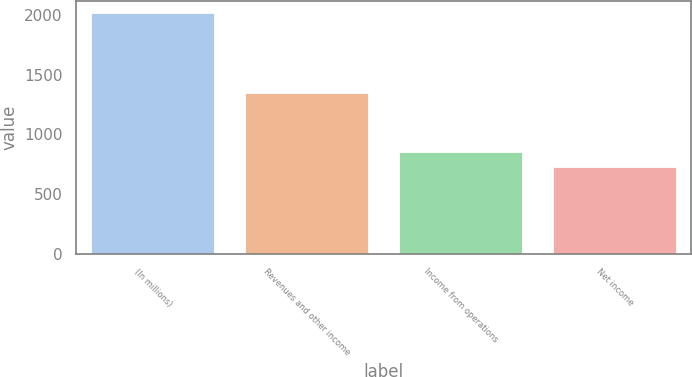Convert chart. <chart><loc_0><loc_0><loc_500><loc_500><bar_chart><fcel>(In millions)<fcel>Revenues and other income<fcel>Income from operations<fcel>Net income<nl><fcel>2014<fcel>1349<fcel>856.6<fcel>728<nl></chart> 